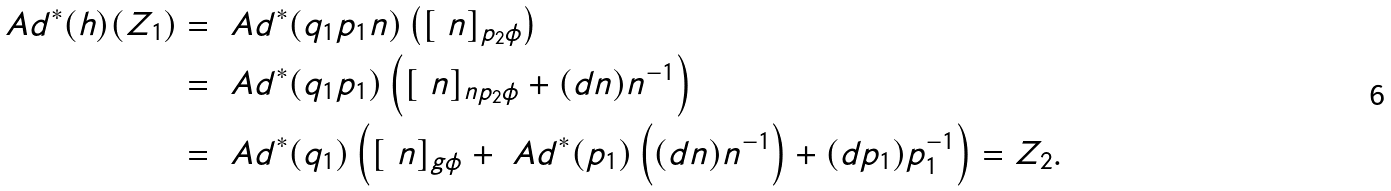<formula> <loc_0><loc_0><loc_500><loc_500>\ A d ^ { * } ( h ) ( Z _ { 1 } ) & = \ A d ^ { * } ( q _ { 1 } p _ { 1 } n ) \left ( [ \ n ] _ { p _ { 2 } \phi } \right ) \\ & = \ A d ^ { * } ( q _ { 1 } p _ { 1 } ) \left ( [ \ n ] _ { n p _ { 2 } \phi } + ( d n ) n ^ { - 1 } \right ) \\ & = \ A d ^ { * } ( q _ { 1 } ) \left ( [ \ n ] _ { g \phi } + \ A d ^ { * } ( p _ { 1 } ) \left ( ( d n ) n ^ { - 1 } \right ) + ( d p _ { 1 } ) p _ { 1 } ^ { - 1 } \right ) = Z _ { 2 } .</formula> 